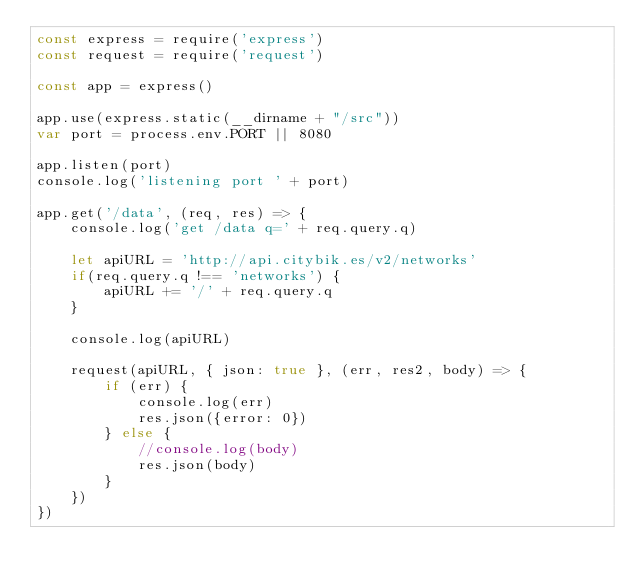Convert code to text. <code><loc_0><loc_0><loc_500><loc_500><_JavaScript_>const express = require('express')
const request = require('request')

const app = express()

app.use(express.static(__dirname + "/src"))
var port = process.env.PORT || 8080

app.listen(port)
console.log('listening port ' + port)

app.get('/data', (req, res) => {
    console.log('get /data q=' + req.query.q)

    let apiURL = 'http://api.citybik.es/v2/networks'
    if(req.query.q !== 'networks') {
        apiURL += '/' + req.query.q
    }

    console.log(apiURL)

    request(apiURL, { json: true }, (err, res2, body) => {
        if (err) {
            console.log(err)
            res.json({error: 0})
        } else {
            //console.log(body)
            res.json(body)
        }
    })
})</code> 